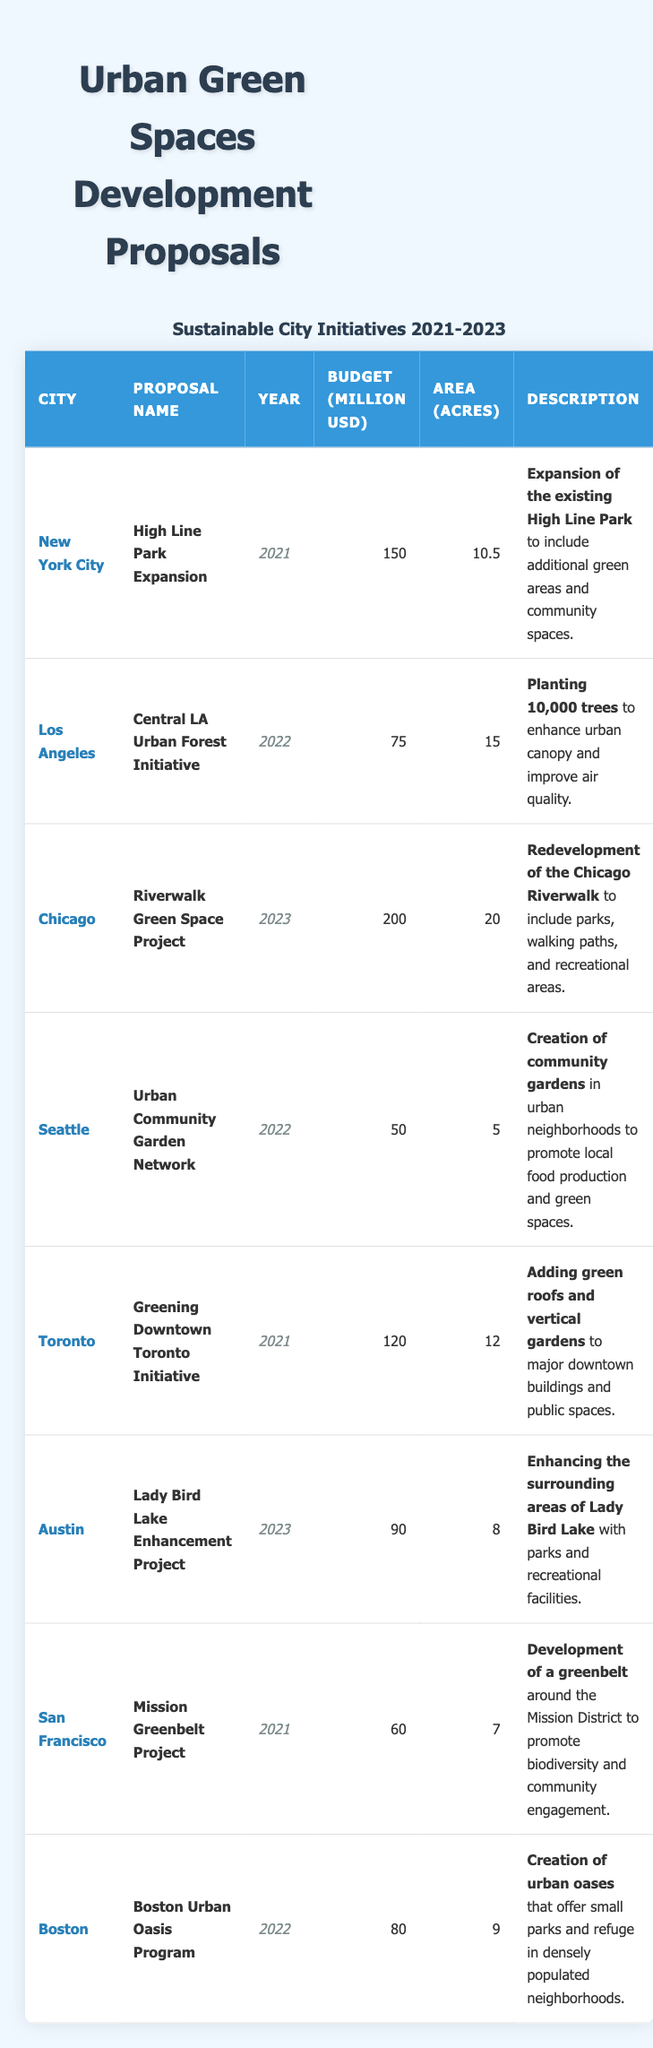What are the budgets of the proposals from Chicago and Los Angeles combined? The budget for the Chicago proposal is 200 million USD, and the budget for the Los Angeles proposal is 75 million USD. Adding them together: 200 + 75 = 275 million USD.
Answer: 275 million USD Which city had the smallest area allocated for its urban green space project? By looking at the "Area (Acres)" column, the smallest area is for Seattle with 5 acres.
Answer: Seattle with 5 acres What is the budget difference between the highest and lowest budget proposals? The highest budget proposal is from Chicago with 200 million USD, and the lowest is from Seattle with 50 million USD. The difference is 200 - 50 = 150 million USD.
Answer: 150 million USD True or False: The **Mission Greenbelt Project** was proposed in 2023. The table shows that the **Mission Greenbelt Project** is listed under the year 2021, so this statement is false.
Answer: False How many acres are proposed for green spaces in total for the year 2022? The proposals for 2022 are from Los Angeles (15 acres), Seattle (5 acres), and Boston (9 acres). Adding these: 15 + 5 + 9 = 29 acres total.
Answer: 29 acres Which city had a proposal with a budget of over 100 million USD in 2021? The 2021 proposals were from New York City (150 million USD) and Toronto (120 million USD). Both exceed 100 million USD.
Answer: New York City and Toronto What is the average budget for the proposals listed? The total budget for all proposals is 150 + 75 + 200 + 50 + 120 + 90 + 60 + 80 = 825 million USD. There are 8 proposals, so the average budget is 825 / 8 = 103.125 million USD.
Answer: 103.125 million USD Name one urban development project that focuses on enhancing biodiversity. The **Mission Greenbelt Project** is directly focused on promoting biodiversity as it aims to develop a greenbelt around the Mission District.
Answer: **Mission Greenbelt Project** How many total acres are proposed for green spaces in New York City and Toronto? The proposal for New York City includes 10.5 acres (High Line Park Expansion) and for Toronto, it includes 12 acres (Greening Downtown Toronto Initiative). Adding them gives: 10.5 + 12 = 22.5 acres.
Answer: 22.5 acres Which proposal aims to plant trees, and how many are planned? The **Central LA Urban Forest Initiative** aims to plant 10,000 trees to enhance the urban canopy.
Answer: **Central LA Urban Forest Initiative**, 10,000 trees 